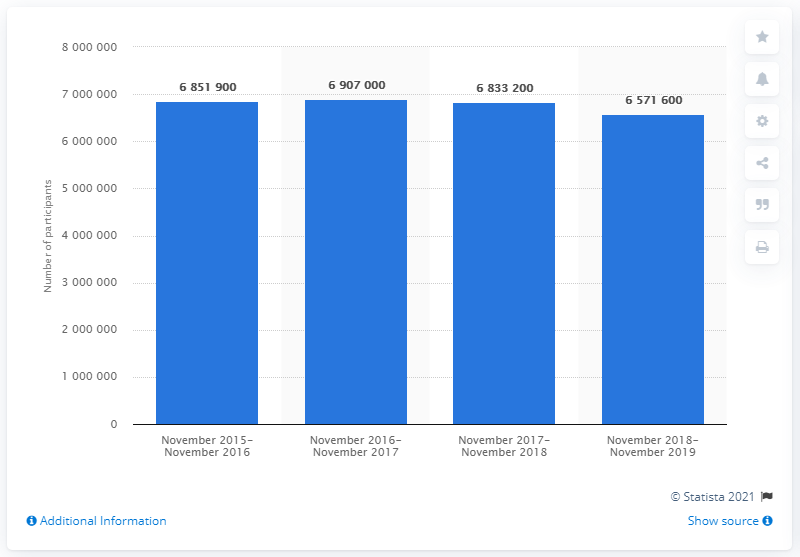Indicate a few pertinent items in this graphic. During the period between November 2018 and November 2019, a total of 683,3200 people in England went running at least twice within 28 days. 